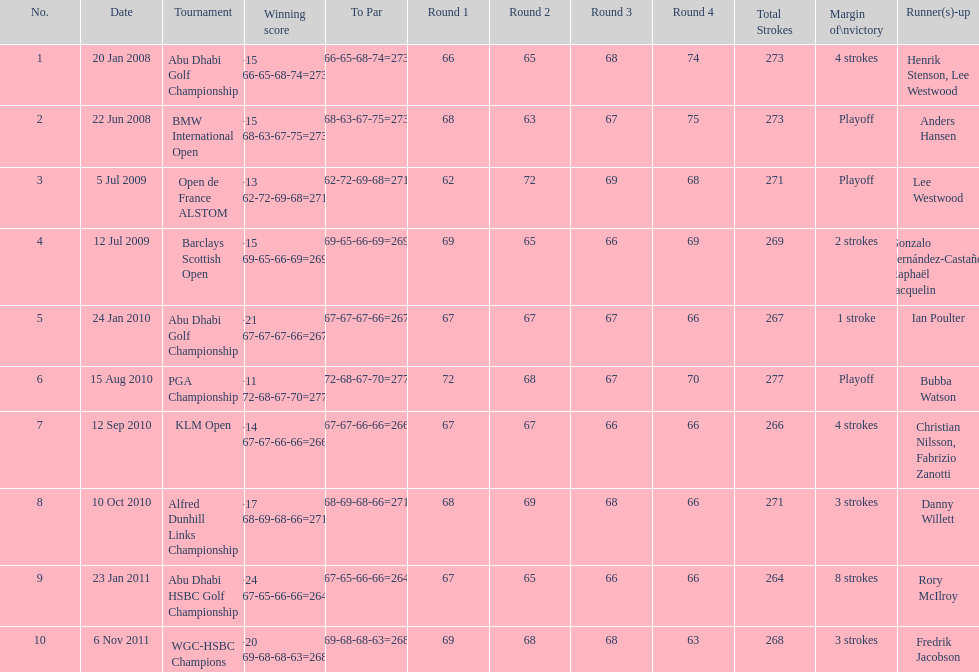How many tournaments has he won by 3 or more strokes? 5. 